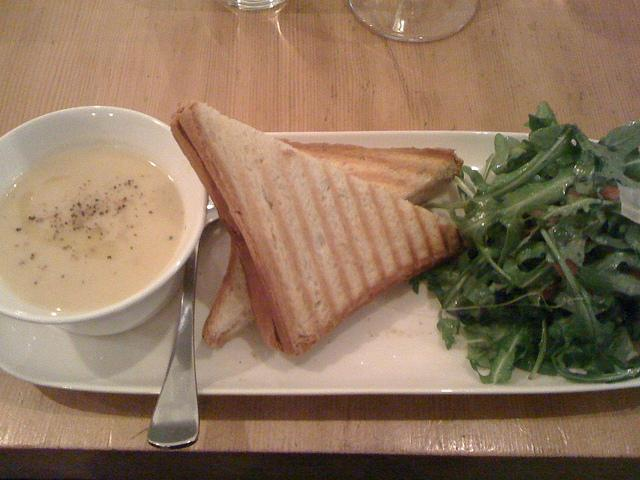Which of the objects on the plate is inedible? Please explain your reasoning. utensil. The soup, bread, and vegetables are edible. the metallic object is not. 